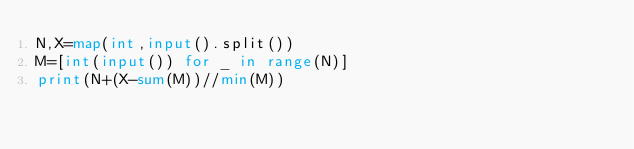Convert code to text. <code><loc_0><loc_0><loc_500><loc_500><_Python_>N,X=map(int,input().split())
M=[int(input()) for _ in range(N)]
print(N+(X-sum(M))//min(M))

</code> 